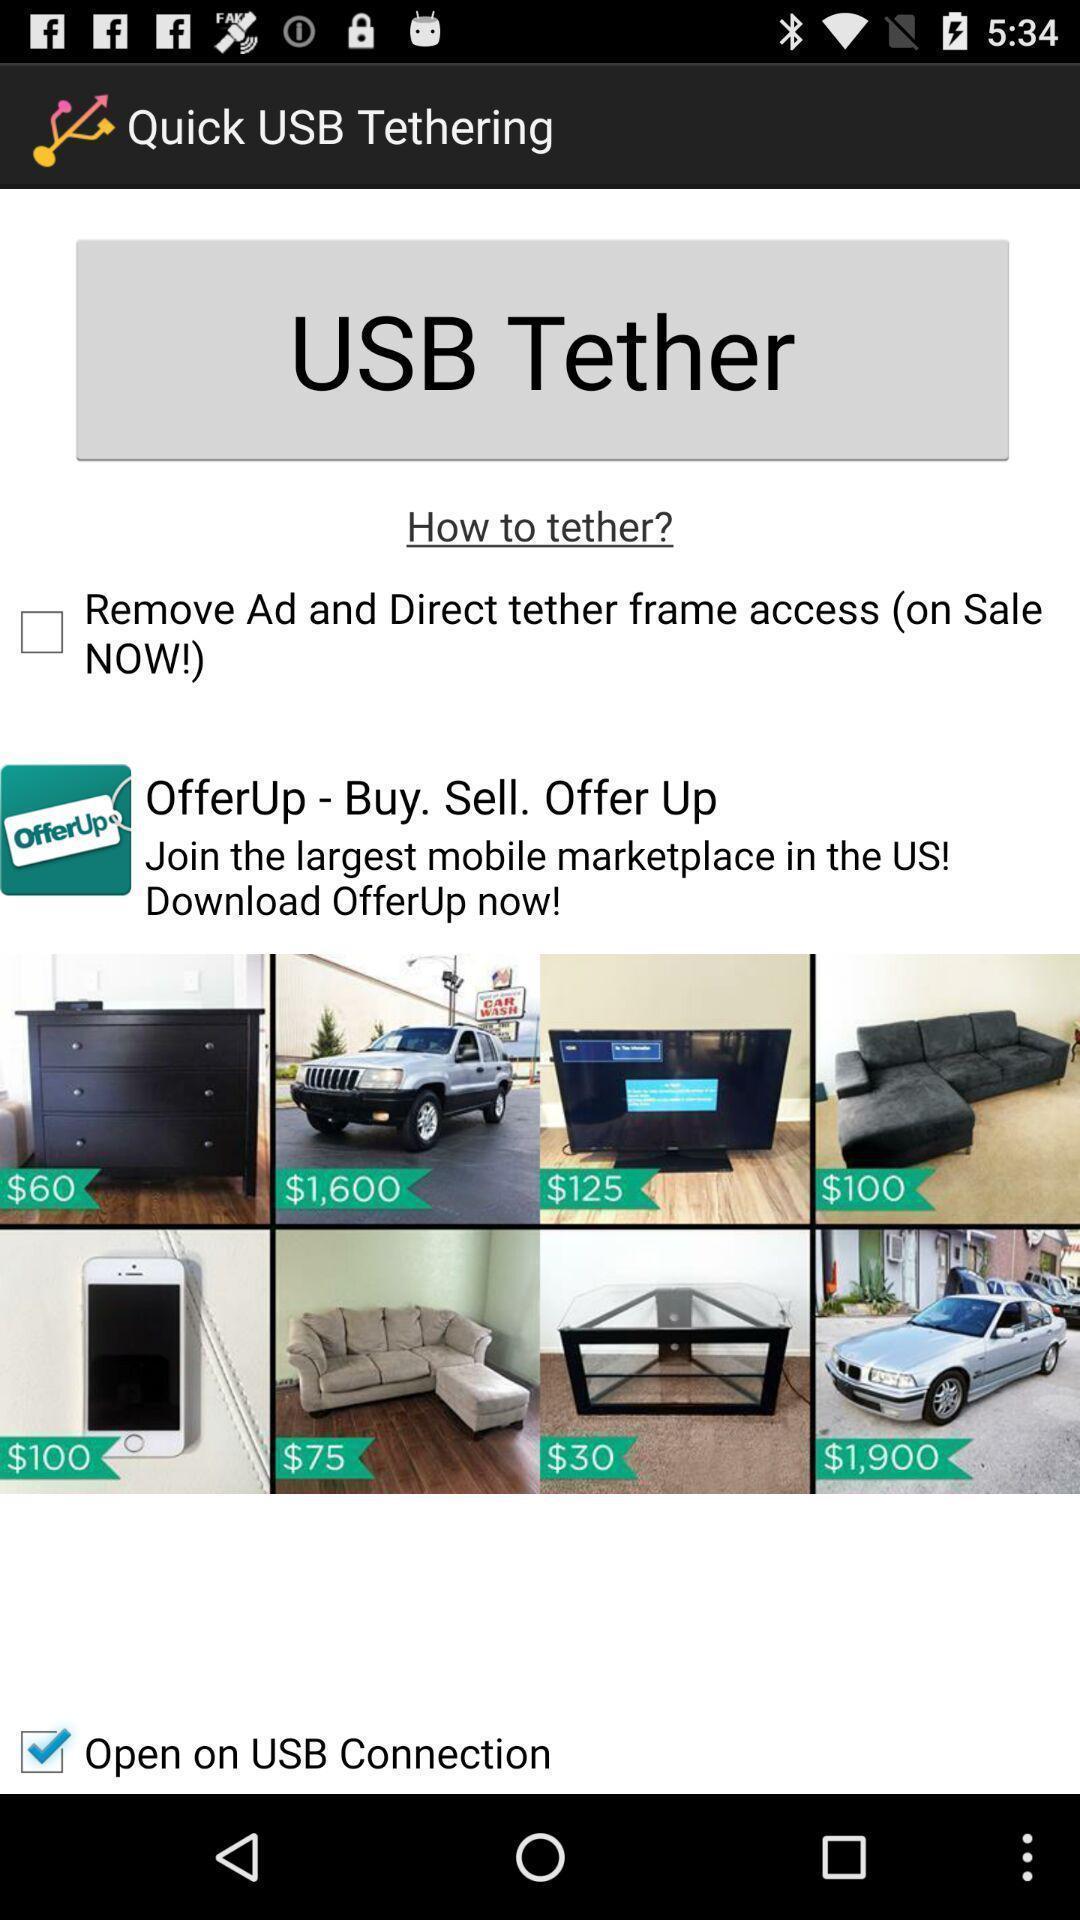Give me a summary of this screen capture. Usb tethering page. 